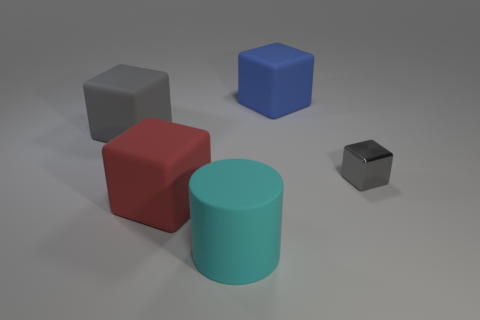How many gray metal blocks have the same size as the blue block?
Provide a succinct answer. 0. What color is the rubber object that is in front of the small gray metallic block and left of the large cyan cylinder?
Your response must be concise. Red. Are there fewer tiny red metallic cylinders than big cyan rubber cylinders?
Offer a terse response. Yes. Is the color of the rubber cylinder the same as the big cube on the right side of the large cyan matte cylinder?
Your answer should be very brief. No. Are there an equal number of large red rubber objects behind the big red rubber cube and rubber cylinders right of the tiny metallic cube?
Your answer should be very brief. Yes. How many red objects are the same shape as the small gray thing?
Your answer should be compact. 1. Are any large brown shiny things visible?
Your answer should be compact. No. Do the cyan thing and the gray cube behind the small metal thing have the same material?
Your answer should be very brief. Yes. There is a cylinder that is the same size as the blue matte block; what material is it?
Your answer should be very brief. Rubber. Is there a large gray block that has the same material as the small cube?
Make the answer very short. No. 